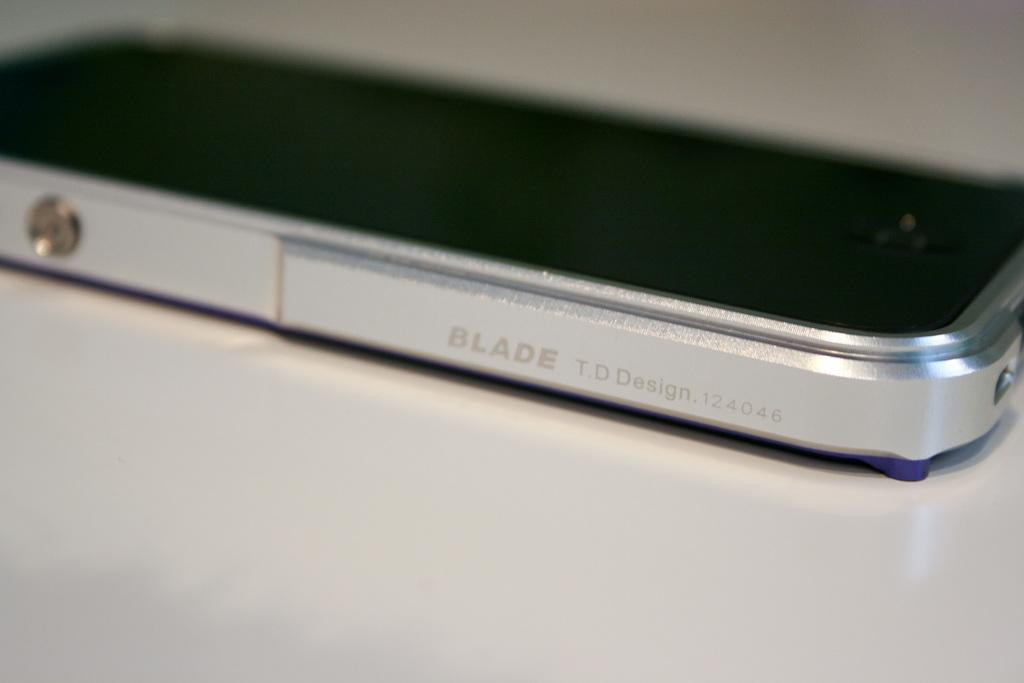<image>
Render a clear and concise summary of the photo. the word blade is on the side of a phone 